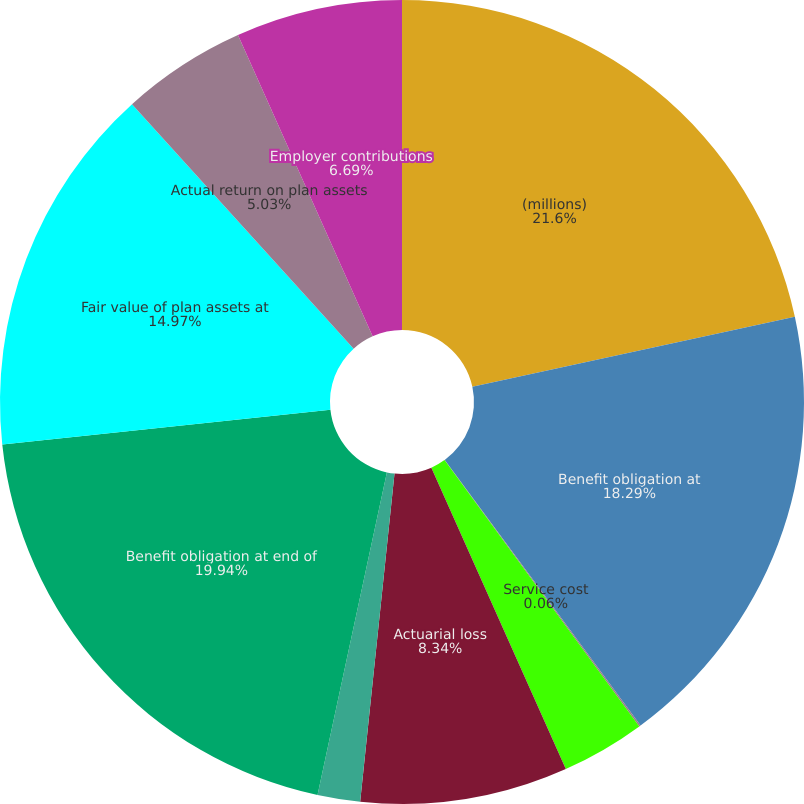Convert chart to OTSL. <chart><loc_0><loc_0><loc_500><loc_500><pie_chart><fcel>(millions)<fcel>Benefit obligation at<fcel>Service cost<fcel>Interest costs<fcel>Actuarial loss<fcel>Benefits paid<fcel>Benefit obligation at end of<fcel>Fair value of plan assets at<fcel>Actual return on plan assets<fcel>Employer contributions<nl><fcel>21.6%<fcel>18.29%<fcel>0.06%<fcel>3.37%<fcel>8.34%<fcel>1.71%<fcel>19.94%<fcel>14.97%<fcel>5.03%<fcel>6.69%<nl></chart> 